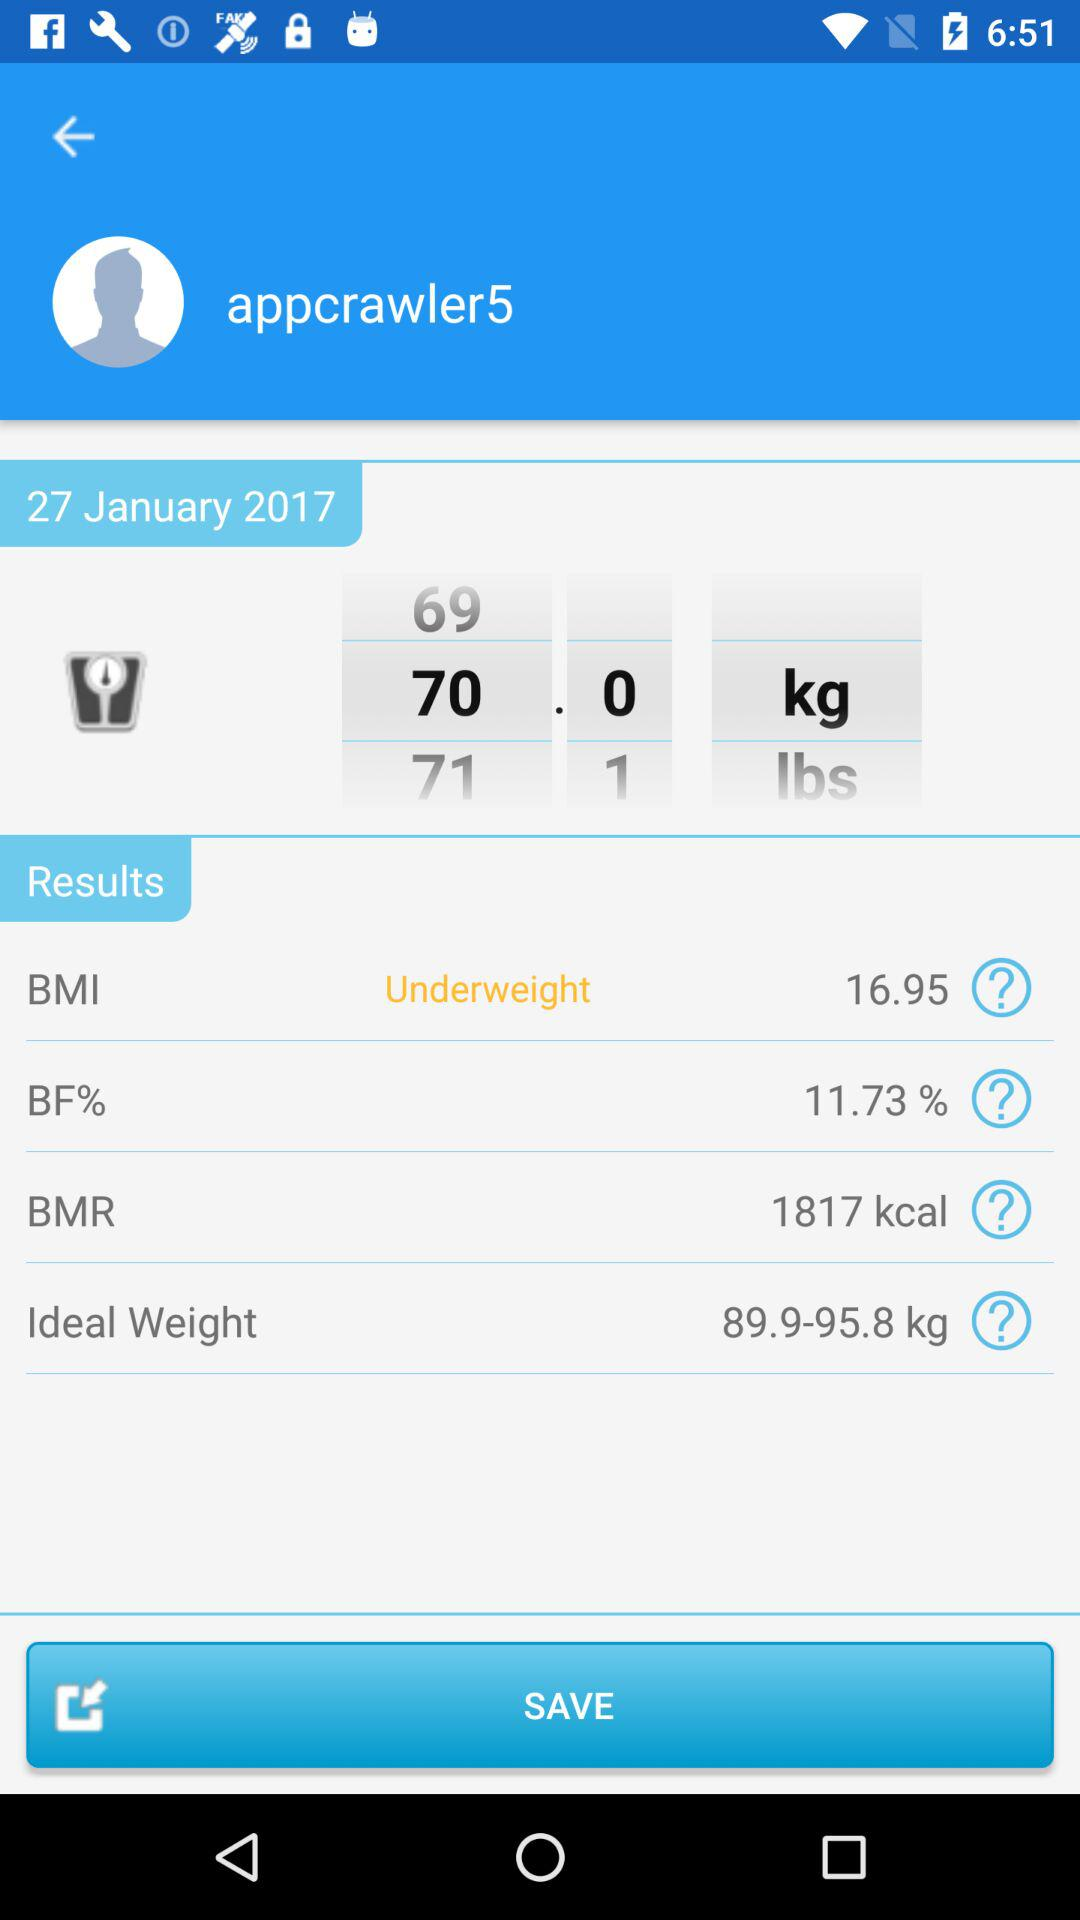What is the user name? The user name is appcrawler5. 